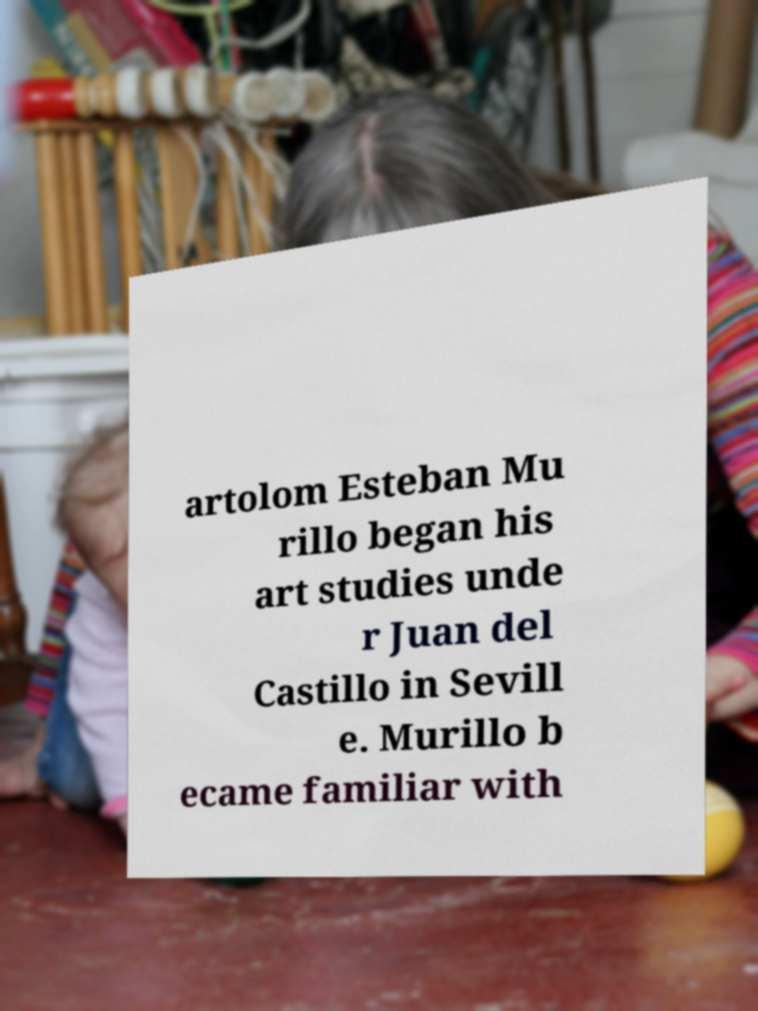Please read and relay the text visible in this image. What does it say? artolom Esteban Mu rillo began his art studies unde r Juan del Castillo in Sevill e. Murillo b ecame familiar with 